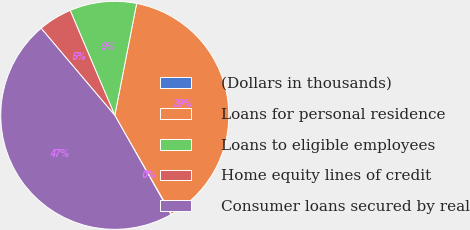Convert chart to OTSL. <chart><loc_0><loc_0><loc_500><loc_500><pie_chart><fcel>(Dollars in thousands)<fcel>Loans for personal residence<fcel>Loans to eligible employees<fcel>Home equity lines of credit<fcel>Consumer loans secured by real<nl><fcel>0.08%<fcel>38.64%<fcel>9.47%<fcel>4.78%<fcel>47.03%<nl></chart> 